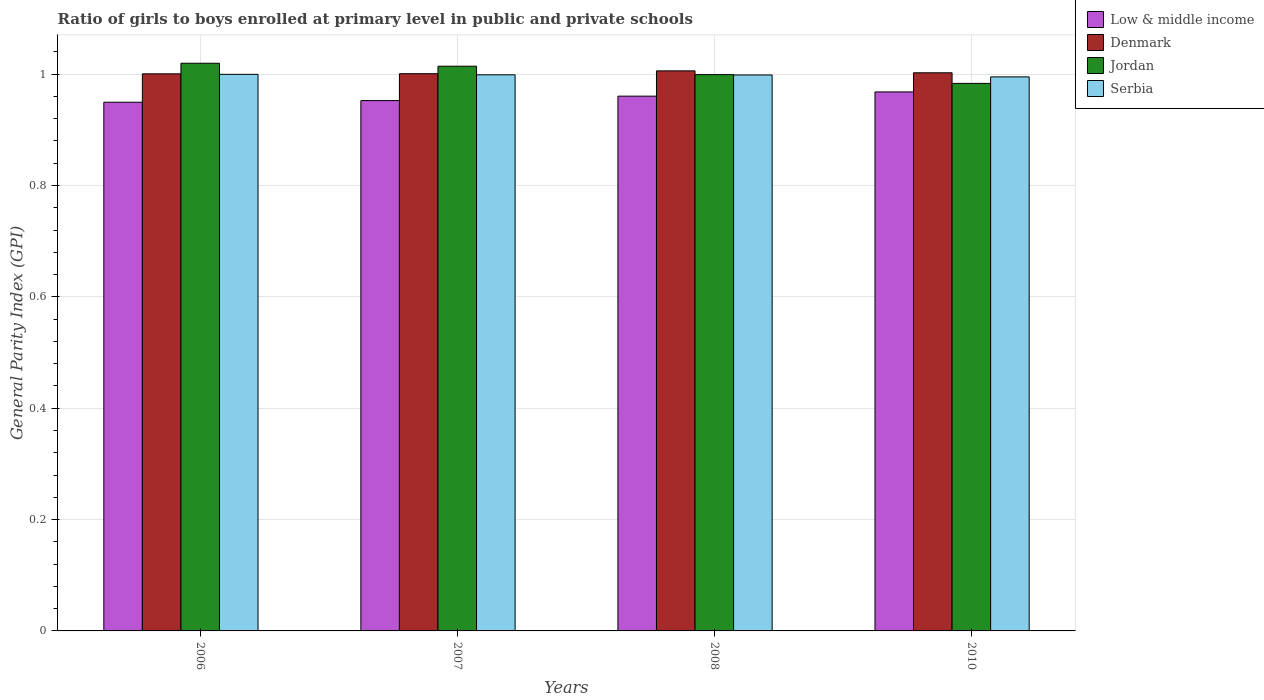How many different coloured bars are there?
Provide a short and direct response. 4. How many groups of bars are there?
Offer a terse response. 4. Are the number of bars on each tick of the X-axis equal?
Your answer should be very brief. Yes. What is the label of the 1st group of bars from the left?
Your answer should be compact. 2006. In how many cases, is the number of bars for a given year not equal to the number of legend labels?
Offer a very short reply. 0. What is the general parity index in Low & middle income in 2010?
Provide a succinct answer. 0.97. Across all years, what is the maximum general parity index in Denmark?
Your answer should be compact. 1.01. Across all years, what is the minimum general parity index in Low & middle income?
Your answer should be very brief. 0.95. In which year was the general parity index in Jordan maximum?
Offer a terse response. 2006. In which year was the general parity index in Serbia minimum?
Your response must be concise. 2010. What is the total general parity index in Jordan in the graph?
Your response must be concise. 4.02. What is the difference between the general parity index in Serbia in 2006 and that in 2007?
Give a very brief answer. 0. What is the difference between the general parity index in Denmark in 2007 and the general parity index in Low & middle income in 2006?
Provide a short and direct response. 0.05. What is the average general parity index in Jordan per year?
Keep it short and to the point. 1. In the year 2008, what is the difference between the general parity index in Denmark and general parity index in Serbia?
Provide a succinct answer. 0.01. What is the ratio of the general parity index in Low & middle income in 2007 to that in 2010?
Provide a succinct answer. 0.98. Is the general parity index in Serbia in 2006 less than that in 2010?
Offer a terse response. No. What is the difference between the highest and the second highest general parity index in Low & middle income?
Keep it short and to the point. 0.01. What is the difference between the highest and the lowest general parity index in Serbia?
Your answer should be compact. 0. In how many years, is the general parity index in Serbia greater than the average general parity index in Serbia taken over all years?
Give a very brief answer. 3. Is the sum of the general parity index in Jordan in 2008 and 2010 greater than the maximum general parity index in Low & middle income across all years?
Make the answer very short. Yes. Is it the case that in every year, the sum of the general parity index in Serbia and general parity index in Low & middle income is greater than the sum of general parity index in Jordan and general parity index in Denmark?
Keep it short and to the point. No. What does the 2nd bar from the left in 2007 represents?
Keep it short and to the point. Denmark. What does the 1st bar from the right in 2008 represents?
Offer a very short reply. Serbia. How many years are there in the graph?
Keep it short and to the point. 4. Does the graph contain any zero values?
Ensure brevity in your answer.  No. Where does the legend appear in the graph?
Make the answer very short. Top right. How are the legend labels stacked?
Your answer should be very brief. Vertical. What is the title of the graph?
Give a very brief answer. Ratio of girls to boys enrolled at primary level in public and private schools. What is the label or title of the Y-axis?
Provide a succinct answer. General Parity Index (GPI). What is the General Parity Index (GPI) in Low & middle income in 2006?
Make the answer very short. 0.95. What is the General Parity Index (GPI) in Denmark in 2006?
Keep it short and to the point. 1. What is the General Parity Index (GPI) of Jordan in 2006?
Keep it short and to the point. 1.02. What is the General Parity Index (GPI) of Serbia in 2006?
Offer a very short reply. 1. What is the General Parity Index (GPI) of Low & middle income in 2007?
Your answer should be very brief. 0.95. What is the General Parity Index (GPI) in Denmark in 2007?
Offer a terse response. 1. What is the General Parity Index (GPI) of Jordan in 2007?
Offer a very short reply. 1.01. What is the General Parity Index (GPI) in Serbia in 2007?
Your answer should be very brief. 1. What is the General Parity Index (GPI) in Low & middle income in 2008?
Make the answer very short. 0.96. What is the General Parity Index (GPI) of Denmark in 2008?
Your response must be concise. 1.01. What is the General Parity Index (GPI) of Jordan in 2008?
Your answer should be very brief. 1. What is the General Parity Index (GPI) in Serbia in 2008?
Provide a succinct answer. 1. What is the General Parity Index (GPI) of Low & middle income in 2010?
Ensure brevity in your answer.  0.97. What is the General Parity Index (GPI) in Denmark in 2010?
Provide a short and direct response. 1. What is the General Parity Index (GPI) of Jordan in 2010?
Provide a succinct answer. 0.98. What is the General Parity Index (GPI) of Serbia in 2010?
Your answer should be very brief. 0.99. Across all years, what is the maximum General Parity Index (GPI) of Low & middle income?
Provide a short and direct response. 0.97. Across all years, what is the maximum General Parity Index (GPI) in Denmark?
Your answer should be very brief. 1.01. Across all years, what is the maximum General Parity Index (GPI) of Jordan?
Provide a succinct answer. 1.02. Across all years, what is the maximum General Parity Index (GPI) in Serbia?
Provide a short and direct response. 1. Across all years, what is the minimum General Parity Index (GPI) in Low & middle income?
Your response must be concise. 0.95. Across all years, what is the minimum General Parity Index (GPI) of Denmark?
Offer a very short reply. 1. Across all years, what is the minimum General Parity Index (GPI) of Jordan?
Ensure brevity in your answer.  0.98. Across all years, what is the minimum General Parity Index (GPI) in Serbia?
Offer a terse response. 0.99. What is the total General Parity Index (GPI) of Low & middle income in the graph?
Provide a succinct answer. 3.83. What is the total General Parity Index (GPI) of Denmark in the graph?
Ensure brevity in your answer.  4.01. What is the total General Parity Index (GPI) in Jordan in the graph?
Ensure brevity in your answer.  4.02. What is the total General Parity Index (GPI) of Serbia in the graph?
Your response must be concise. 3.99. What is the difference between the General Parity Index (GPI) of Low & middle income in 2006 and that in 2007?
Keep it short and to the point. -0. What is the difference between the General Parity Index (GPI) in Denmark in 2006 and that in 2007?
Offer a terse response. -0. What is the difference between the General Parity Index (GPI) in Jordan in 2006 and that in 2007?
Give a very brief answer. 0.01. What is the difference between the General Parity Index (GPI) in Serbia in 2006 and that in 2007?
Your answer should be very brief. 0. What is the difference between the General Parity Index (GPI) of Low & middle income in 2006 and that in 2008?
Keep it short and to the point. -0.01. What is the difference between the General Parity Index (GPI) of Denmark in 2006 and that in 2008?
Provide a short and direct response. -0.01. What is the difference between the General Parity Index (GPI) in Jordan in 2006 and that in 2008?
Provide a succinct answer. 0.02. What is the difference between the General Parity Index (GPI) in Serbia in 2006 and that in 2008?
Offer a terse response. 0. What is the difference between the General Parity Index (GPI) in Low & middle income in 2006 and that in 2010?
Provide a short and direct response. -0.02. What is the difference between the General Parity Index (GPI) in Denmark in 2006 and that in 2010?
Ensure brevity in your answer.  -0. What is the difference between the General Parity Index (GPI) of Jordan in 2006 and that in 2010?
Your answer should be compact. 0.04. What is the difference between the General Parity Index (GPI) of Serbia in 2006 and that in 2010?
Offer a very short reply. 0. What is the difference between the General Parity Index (GPI) of Low & middle income in 2007 and that in 2008?
Ensure brevity in your answer.  -0.01. What is the difference between the General Parity Index (GPI) of Denmark in 2007 and that in 2008?
Make the answer very short. -0.01. What is the difference between the General Parity Index (GPI) of Jordan in 2007 and that in 2008?
Provide a succinct answer. 0.02. What is the difference between the General Parity Index (GPI) of Serbia in 2007 and that in 2008?
Ensure brevity in your answer.  0. What is the difference between the General Parity Index (GPI) in Low & middle income in 2007 and that in 2010?
Your answer should be compact. -0.02. What is the difference between the General Parity Index (GPI) in Denmark in 2007 and that in 2010?
Provide a succinct answer. -0. What is the difference between the General Parity Index (GPI) in Jordan in 2007 and that in 2010?
Offer a very short reply. 0.03. What is the difference between the General Parity Index (GPI) in Serbia in 2007 and that in 2010?
Give a very brief answer. 0. What is the difference between the General Parity Index (GPI) in Low & middle income in 2008 and that in 2010?
Your response must be concise. -0.01. What is the difference between the General Parity Index (GPI) in Denmark in 2008 and that in 2010?
Ensure brevity in your answer.  0. What is the difference between the General Parity Index (GPI) of Jordan in 2008 and that in 2010?
Provide a succinct answer. 0.02. What is the difference between the General Parity Index (GPI) in Serbia in 2008 and that in 2010?
Your response must be concise. 0. What is the difference between the General Parity Index (GPI) in Low & middle income in 2006 and the General Parity Index (GPI) in Denmark in 2007?
Your answer should be compact. -0.05. What is the difference between the General Parity Index (GPI) of Low & middle income in 2006 and the General Parity Index (GPI) of Jordan in 2007?
Your response must be concise. -0.06. What is the difference between the General Parity Index (GPI) of Low & middle income in 2006 and the General Parity Index (GPI) of Serbia in 2007?
Your answer should be very brief. -0.05. What is the difference between the General Parity Index (GPI) in Denmark in 2006 and the General Parity Index (GPI) in Jordan in 2007?
Offer a very short reply. -0.01. What is the difference between the General Parity Index (GPI) of Denmark in 2006 and the General Parity Index (GPI) of Serbia in 2007?
Make the answer very short. 0. What is the difference between the General Parity Index (GPI) in Jordan in 2006 and the General Parity Index (GPI) in Serbia in 2007?
Offer a very short reply. 0.02. What is the difference between the General Parity Index (GPI) in Low & middle income in 2006 and the General Parity Index (GPI) in Denmark in 2008?
Your answer should be very brief. -0.06. What is the difference between the General Parity Index (GPI) of Low & middle income in 2006 and the General Parity Index (GPI) of Jordan in 2008?
Your answer should be very brief. -0.05. What is the difference between the General Parity Index (GPI) of Low & middle income in 2006 and the General Parity Index (GPI) of Serbia in 2008?
Offer a terse response. -0.05. What is the difference between the General Parity Index (GPI) in Denmark in 2006 and the General Parity Index (GPI) in Jordan in 2008?
Offer a terse response. 0. What is the difference between the General Parity Index (GPI) of Denmark in 2006 and the General Parity Index (GPI) of Serbia in 2008?
Your answer should be compact. 0. What is the difference between the General Parity Index (GPI) in Jordan in 2006 and the General Parity Index (GPI) in Serbia in 2008?
Provide a short and direct response. 0.02. What is the difference between the General Parity Index (GPI) of Low & middle income in 2006 and the General Parity Index (GPI) of Denmark in 2010?
Your response must be concise. -0.05. What is the difference between the General Parity Index (GPI) of Low & middle income in 2006 and the General Parity Index (GPI) of Jordan in 2010?
Offer a very short reply. -0.03. What is the difference between the General Parity Index (GPI) in Low & middle income in 2006 and the General Parity Index (GPI) in Serbia in 2010?
Your response must be concise. -0.05. What is the difference between the General Parity Index (GPI) in Denmark in 2006 and the General Parity Index (GPI) in Jordan in 2010?
Make the answer very short. 0.02. What is the difference between the General Parity Index (GPI) in Denmark in 2006 and the General Parity Index (GPI) in Serbia in 2010?
Your answer should be very brief. 0.01. What is the difference between the General Parity Index (GPI) of Jordan in 2006 and the General Parity Index (GPI) of Serbia in 2010?
Your answer should be very brief. 0.02. What is the difference between the General Parity Index (GPI) in Low & middle income in 2007 and the General Parity Index (GPI) in Denmark in 2008?
Your answer should be very brief. -0.05. What is the difference between the General Parity Index (GPI) of Low & middle income in 2007 and the General Parity Index (GPI) of Jordan in 2008?
Make the answer very short. -0.05. What is the difference between the General Parity Index (GPI) in Low & middle income in 2007 and the General Parity Index (GPI) in Serbia in 2008?
Your response must be concise. -0.05. What is the difference between the General Parity Index (GPI) in Denmark in 2007 and the General Parity Index (GPI) in Jordan in 2008?
Keep it short and to the point. 0. What is the difference between the General Parity Index (GPI) of Denmark in 2007 and the General Parity Index (GPI) of Serbia in 2008?
Keep it short and to the point. 0. What is the difference between the General Parity Index (GPI) of Jordan in 2007 and the General Parity Index (GPI) of Serbia in 2008?
Make the answer very short. 0.02. What is the difference between the General Parity Index (GPI) of Low & middle income in 2007 and the General Parity Index (GPI) of Denmark in 2010?
Your answer should be compact. -0.05. What is the difference between the General Parity Index (GPI) in Low & middle income in 2007 and the General Parity Index (GPI) in Jordan in 2010?
Give a very brief answer. -0.03. What is the difference between the General Parity Index (GPI) in Low & middle income in 2007 and the General Parity Index (GPI) in Serbia in 2010?
Offer a very short reply. -0.04. What is the difference between the General Parity Index (GPI) in Denmark in 2007 and the General Parity Index (GPI) in Jordan in 2010?
Make the answer very short. 0.02. What is the difference between the General Parity Index (GPI) in Denmark in 2007 and the General Parity Index (GPI) in Serbia in 2010?
Make the answer very short. 0.01. What is the difference between the General Parity Index (GPI) in Jordan in 2007 and the General Parity Index (GPI) in Serbia in 2010?
Provide a succinct answer. 0.02. What is the difference between the General Parity Index (GPI) in Low & middle income in 2008 and the General Parity Index (GPI) in Denmark in 2010?
Make the answer very short. -0.04. What is the difference between the General Parity Index (GPI) in Low & middle income in 2008 and the General Parity Index (GPI) in Jordan in 2010?
Offer a terse response. -0.02. What is the difference between the General Parity Index (GPI) in Low & middle income in 2008 and the General Parity Index (GPI) in Serbia in 2010?
Your answer should be very brief. -0.03. What is the difference between the General Parity Index (GPI) in Denmark in 2008 and the General Parity Index (GPI) in Jordan in 2010?
Your answer should be compact. 0.02. What is the difference between the General Parity Index (GPI) in Denmark in 2008 and the General Parity Index (GPI) in Serbia in 2010?
Your answer should be compact. 0.01. What is the difference between the General Parity Index (GPI) of Jordan in 2008 and the General Parity Index (GPI) of Serbia in 2010?
Offer a terse response. 0. What is the average General Parity Index (GPI) of Low & middle income per year?
Ensure brevity in your answer.  0.96. In the year 2006, what is the difference between the General Parity Index (GPI) in Low & middle income and General Parity Index (GPI) in Denmark?
Your answer should be very brief. -0.05. In the year 2006, what is the difference between the General Parity Index (GPI) in Low & middle income and General Parity Index (GPI) in Jordan?
Your response must be concise. -0.07. In the year 2006, what is the difference between the General Parity Index (GPI) in Low & middle income and General Parity Index (GPI) in Serbia?
Your answer should be very brief. -0.05. In the year 2006, what is the difference between the General Parity Index (GPI) in Denmark and General Parity Index (GPI) in Jordan?
Offer a terse response. -0.02. In the year 2006, what is the difference between the General Parity Index (GPI) in Denmark and General Parity Index (GPI) in Serbia?
Offer a very short reply. 0. In the year 2006, what is the difference between the General Parity Index (GPI) in Jordan and General Parity Index (GPI) in Serbia?
Give a very brief answer. 0.02. In the year 2007, what is the difference between the General Parity Index (GPI) in Low & middle income and General Parity Index (GPI) in Denmark?
Keep it short and to the point. -0.05. In the year 2007, what is the difference between the General Parity Index (GPI) of Low & middle income and General Parity Index (GPI) of Jordan?
Your answer should be compact. -0.06. In the year 2007, what is the difference between the General Parity Index (GPI) in Low & middle income and General Parity Index (GPI) in Serbia?
Ensure brevity in your answer.  -0.05. In the year 2007, what is the difference between the General Parity Index (GPI) of Denmark and General Parity Index (GPI) of Jordan?
Give a very brief answer. -0.01. In the year 2007, what is the difference between the General Parity Index (GPI) of Denmark and General Parity Index (GPI) of Serbia?
Ensure brevity in your answer.  0. In the year 2007, what is the difference between the General Parity Index (GPI) in Jordan and General Parity Index (GPI) in Serbia?
Offer a terse response. 0.02. In the year 2008, what is the difference between the General Parity Index (GPI) in Low & middle income and General Parity Index (GPI) in Denmark?
Ensure brevity in your answer.  -0.05. In the year 2008, what is the difference between the General Parity Index (GPI) of Low & middle income and General Parity Index (GPI) of Jordan?
Keep it short and to the point. -0.04. In the year 2008, what is the difference between the General Parity Index (GPI) in Low & middle income and General Parity Index (GPI) in Serbia?
Give a very brief answer. -0.04. In the year 2008, what is the difference between the General Parity Index (GPI) in Denmark and General Parity Index (GPI) in Jordan?
Your response must be concise. 0.01. In the year 2008, what is the difference between the General Parity Index (GPI) in Denmark and General Parity Index (GPI) in Serbia?
Ensure brevity in your answer.  0.01. In the year 2008, what is the difference between the General Parity Index (GPI) in Jordan and General Parity Index (GPI) in Serbia?
Your answer should be very brief. 0. In the year 2010, what is the difference between the General Parity Index (GPI) in Low & middle income and General Parity Index (GPI) in Denmark?
Keep it short and to the point. -0.03. In the year 2010, what is the difference between the General Parity Index (GPI) in Low & middle income and General Parity Index (GPI) in Jordan?
Give a very brief answer. -0.02. In the year 2010, what is the difference between the General Parity Index (GPI) of Low & middle income and General Parity Index (GPI) of Serbia?
Keep it short and to the point. -0.03. In the year 2010, what is the difference between the General Parity Index (GPI) of Denmark and General Parity Index (GPI) of Jordan?
Your answer should be compact. 0.02. In the year 2010, what is the difference between the General Parity Index (GPI) of Denmark and General Parity Index (GPI) of Serbia?
Provide a short and direct response. 0.01. In the year 2010, what is the difference between the General Parity Index (GPI) in Jordan and General Parity Index (GPI) in Serbia?
Keep it short and to the point. -0.01. What is the ratio of the General Parity Index (GPI) in Low & middle income in 2006 to that in 2007?
Provide a short and direct response. 1. What is the ratio of the General Parity Index (GPI) in Denmark in 2006 to that in 2007?
Keep it short and to the point. 1. What is the ratio of the General Parity Index (GPI) in Jordan in 2006 to that in 2007?
Your response must be concise. 1.01. What is the ratio of the General Parity Index (GPI) in Serbia in 2006 to that in 2007?
Your response must be concise. 1. What is the ratio of the General Parity Index (GPI) in Low & middle income in 2006 to that in 2008?
Make the answer very short. 0.99. What is the ratio of the General Parity Index (GPI) of Denmark in 2006 to that in 2008?
Provide a short and direct response. 0.99. What is the ratio of the General Parity Index (GPI) in Jordan in 2006 to that in 2008?
Your response must be concise. 1.02. What is the ratio of the General Parity Index (GPI) of Low & middle income in 2006 to that in 2010?
Your response must be concise. 0.98. What is the ratio of the General Parity Index (GPI) of Denmark in 2006 to that in 2010?
Provide a short and direct response. 1. What is the ratio of the General Parity Index (GPI) in Jordan in 2006 to that in 2010?
Give a very brief answer. 1.04. What is the ratio of the General Parity Index (GPI) in Low & middle income in 2007 to that in 2008?
Provide a short and direct response. 0.99. What is the ratio of the General Parity Index (GPI) in Denmark in 2007 to that in 2008?
Your answer should be very brief. 0.99. What is the ratio of the General Parity Index (GPI) of Jordan in 2007 to that in 2008?
Give a very brief answer. 1.02. What is the ratio of the General Parity Index (GPI) of Serbia in 2007 to that in 2008?
Provide a succinct answer. 1. What is the ratio of the General Parity Index (GPI) of Low & middle income in 2007 to that in 2010?
Ensure brevity in your answer.  0.98. What is the ratio of the General Parity Index (GPI) of Jordan in 2007 to that in 2010?
Your answer should be very brief. 1.03. What is the ratio of the General Parity Index (GPI) in Low & middle income in 2008 to that in 2010?
Provide a short and direct response. 0.99. What is the ratio of the General Parity Index (GPI) of Jordan in 2008 to that in 2010?
Make the answer very short. 1.02. What is the difference between the highest and the second highest General Parity Index (GPI) of Low & middle income?
Provide a succinct answer. 0.01. What is the difference between the highest and the second highest General Parity Index (GPI) of Denmark?
Offer a very short reply. 0. What is the difference between the highest and the second highest General Parity Index (GPI) in Jordan?
Ensure brevity in your answer.  0.01. What is the difference between the highest and the second highest General Parity Index (GPI) of Serbia?
Make the answer very short. 0. What is the difference between the highest and the lowest General Parity Index (GPI) of Low & middle income?
Offer a terse response. 0.02. What is the difference between the highest and the lowest General Parity Index (GPI) in Denmark?
Offer a very short reply. 0.01. What is the difference between the highest and the lowest General Parity Index (GPI) in Jordan?
Provide a succinct answer. 0.04. What is the difference between the highest and the lowest General Parity Index (GPI) of Serbia?
Your answer should be compact. 0. 